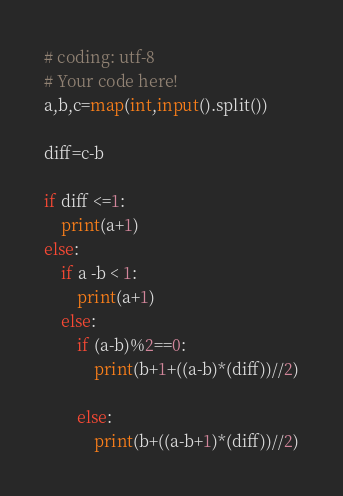Convert code to text. <code><loc_0><loc_0><loc_500><loc_500><_Python_># coding: utf-8
# Your code here!
a,b,c=map(int,input().split())

diff=c-b

if diff <=1:
    print(a+1)
else:
    if a -b < 1:
        print(a+1)
    else:
        if (a-b)%2==0:
            print(b+1+((a-b)*(diff))//2)
        
        else:
            print(b+((a-b+1)*(diff))//2)</code> 